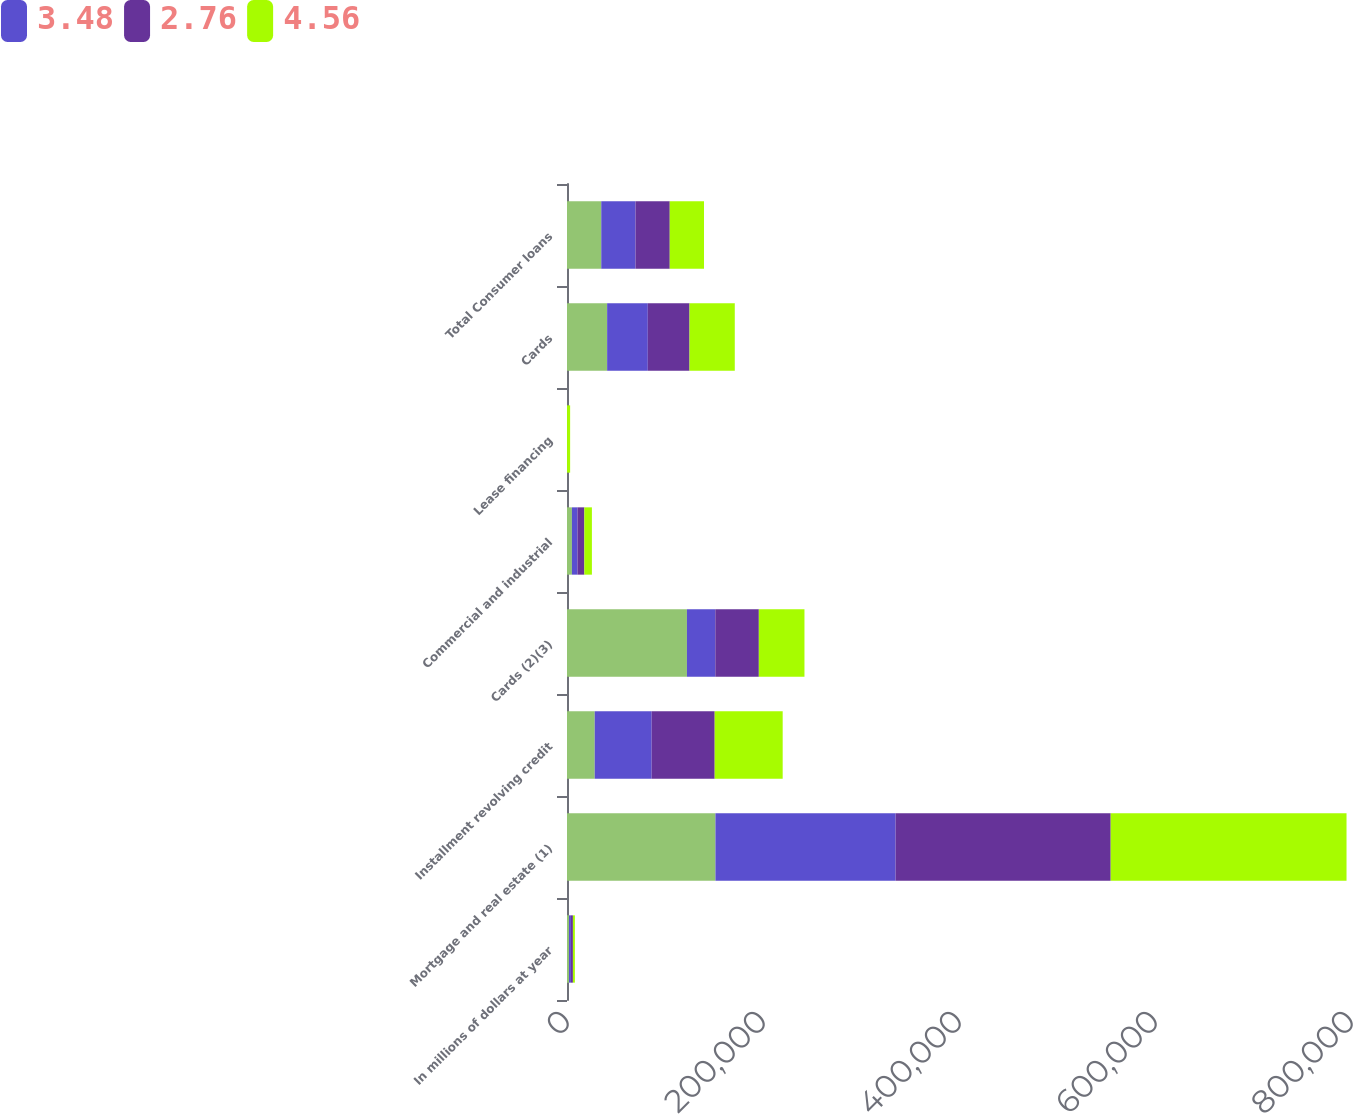Convert chart. <chart><loc_0><loc_0><loc_500><loc_500><stacked_bar_chart><ecel><fcel>In millions of dollars at year<fcel>Mortgage and real estate (1)<fcel>Installment revolving credit<fcel>Cards (2)(3)<fcel>Commercial and industrial<fcel>Lease financing<fcel>Cards<fcel>Total Consumer loans<nl><fcel>nan<fcel>2010<fcel>151469<fcel>28291<fcel>122384<fcel>5021<fcel>2<fcel>40948<fcel>34949.5<nl><fcel>3.48<fcel>2009<fcel>183842<fcel>58099<fcel>28951<fcel>5640<fcel>11<fcel>41493<fcel>34949.5<nl><fcel>2.76<fcel>2008<fcel>219482<fcel>64319<fcel>44418<fcel>7041<fcel>31<fcel>42586<fcel>34949.5<nl><fcel>4.56<fcel>2007<fcel>240644<fcel>69379<fcel>46559<fcel>7716<fcel>3151<fcel>46176<fcel>34949.5<nl></chart> 